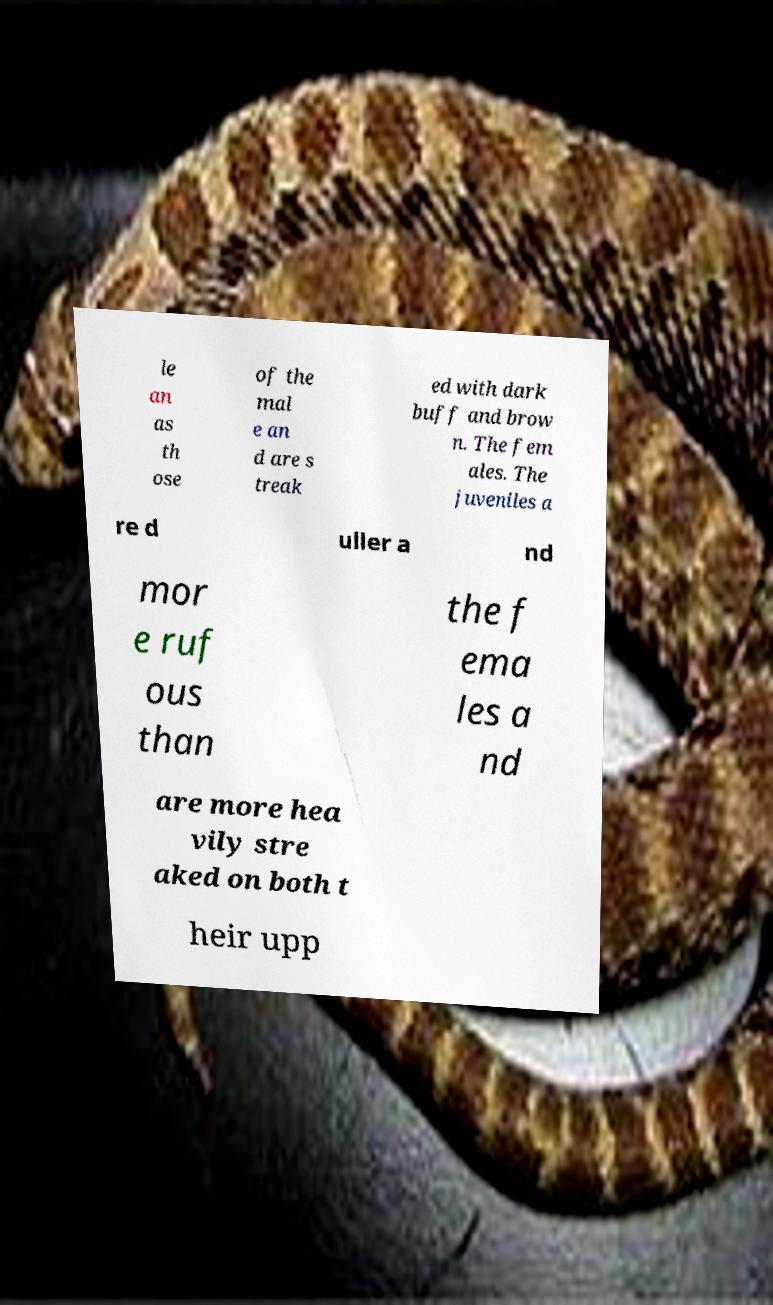Could you extract and type out the text from this image? le an as th ose of the mal e an d are s treak ed with dark buff and brow n. The fem ales. The juveniles a re d uller a nd mor e ruf ous than the f ema les a nd are more hea vily stre aked on both t heir upp 